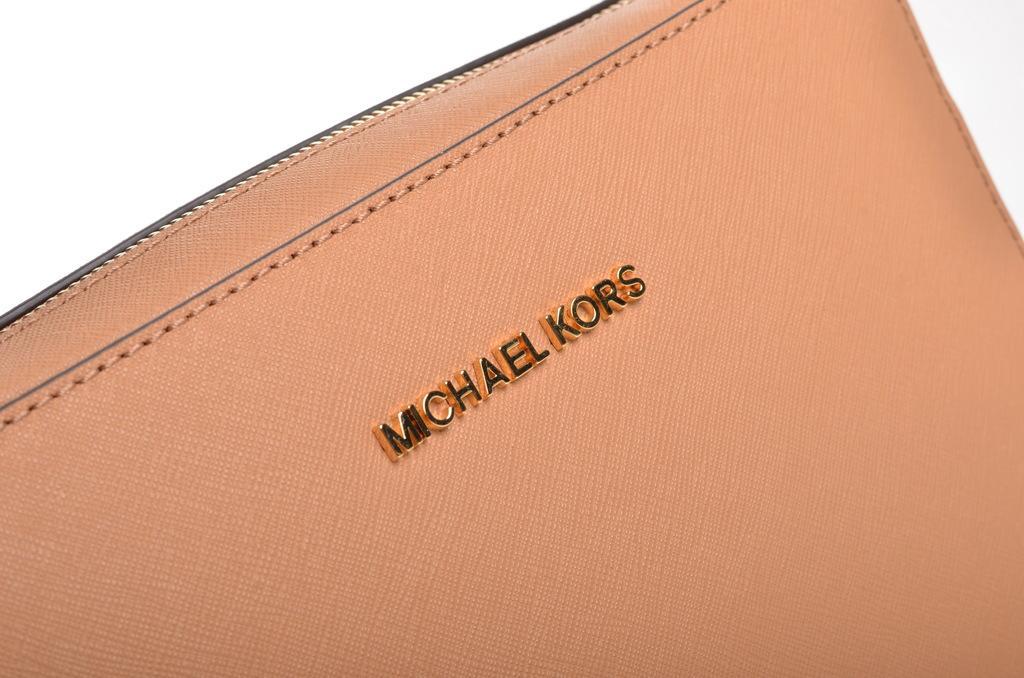How would you summarize this image in a sentence or two? In this image there is a purse with some text written on it. 